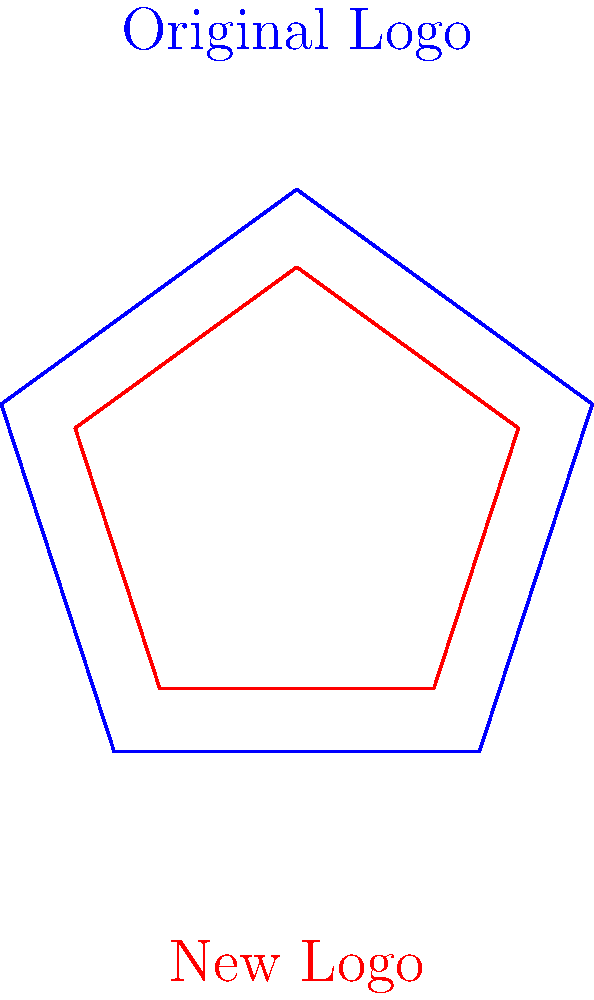The school's logo before and after closure was a regular pentagon. If the area of the new logo is 56.25% of the original logo's area, what is the scale factor of the new logo compared to the original? Let's approach this step-by-step:

1) First, recall that for similar shapes, the ratio of their areas is equal to the square of the ratio of their linear dimensions. In other words:

   $\frac{Area_{new}}{Area_{original}} = (\frac{side_{new}}{side_{original}})^2$

2) We're given that the area of the new logo is 56.25% of the original logo's area. This means:

   $\frac{Area_{new}}{Area_{original}} = 0.5625$

3) Let's call the scale factor $x$. This is the ratio of the sides:

   $x = \frac{side_{new}}{side_{original}}$

4) Using the relationship from step 1:

   $0.5625 = x^2$

5) To solve for $x$, we take the square root of both sides:

   $x = \sqrt{0.5625}$

6) Simplify:

   $x = 0.75$

Thus, the scale factor of the new logo compared to the original is 0.75 or 75%.
Answer: 0.75 